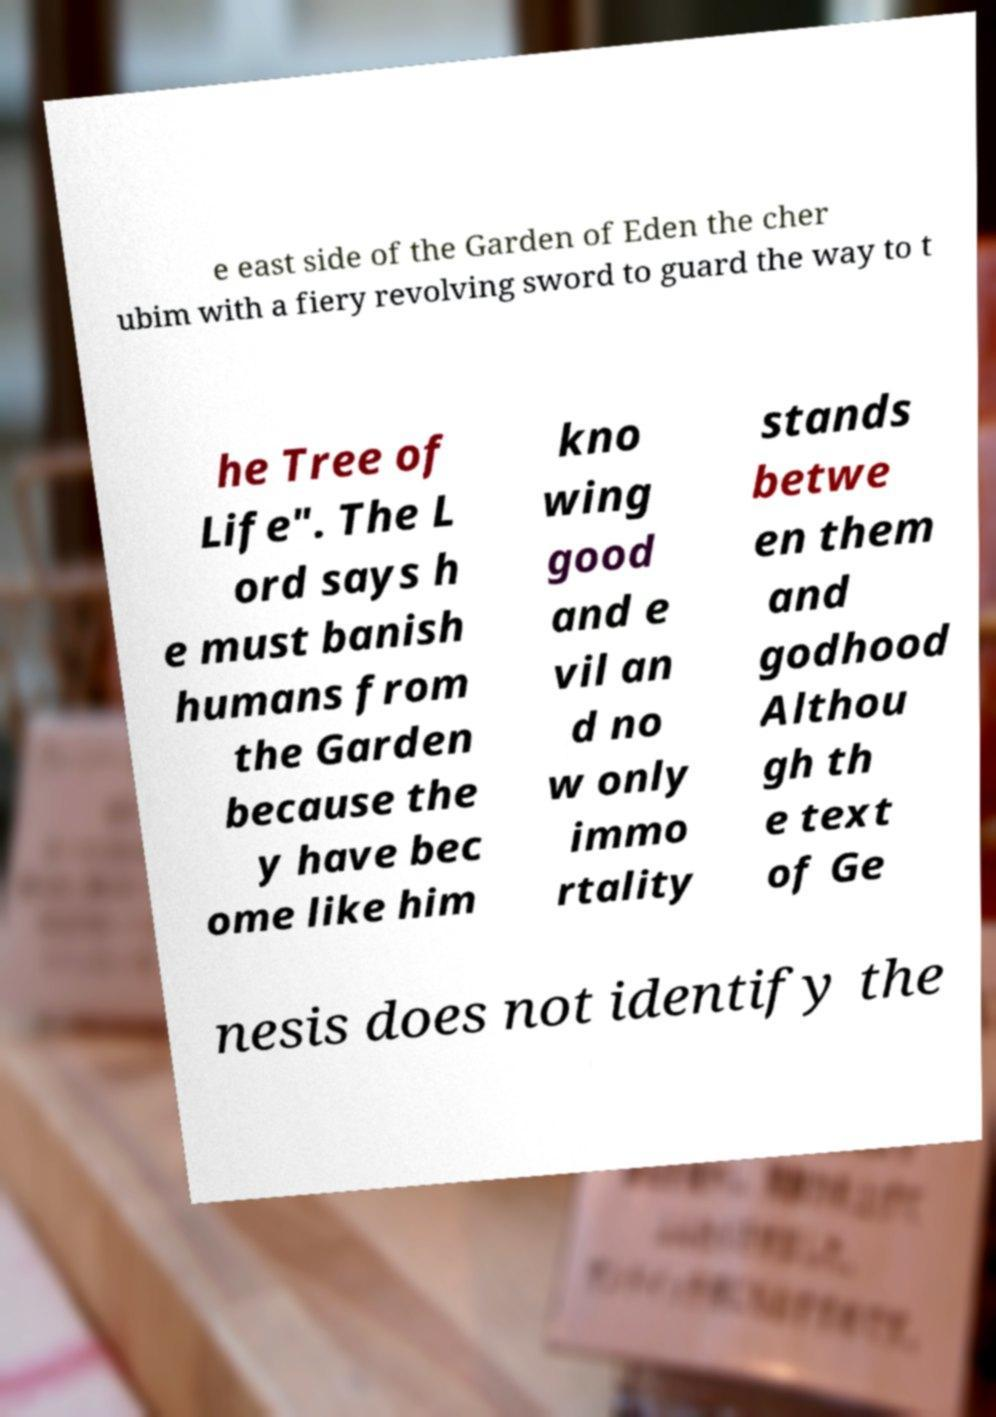Could you extract and type out the text from this image? e east side of the Garden of Eden the cher ubim with a fiery revolving sword to guard the way to t he Tree of Life". The L ord says h e must banish humans from the Garden because the y have bec ome like him kno wing good and e vil an d no w only immo rtality stands betwe en them and godhood Althou gh th e text of Ge nesis does not identify the 